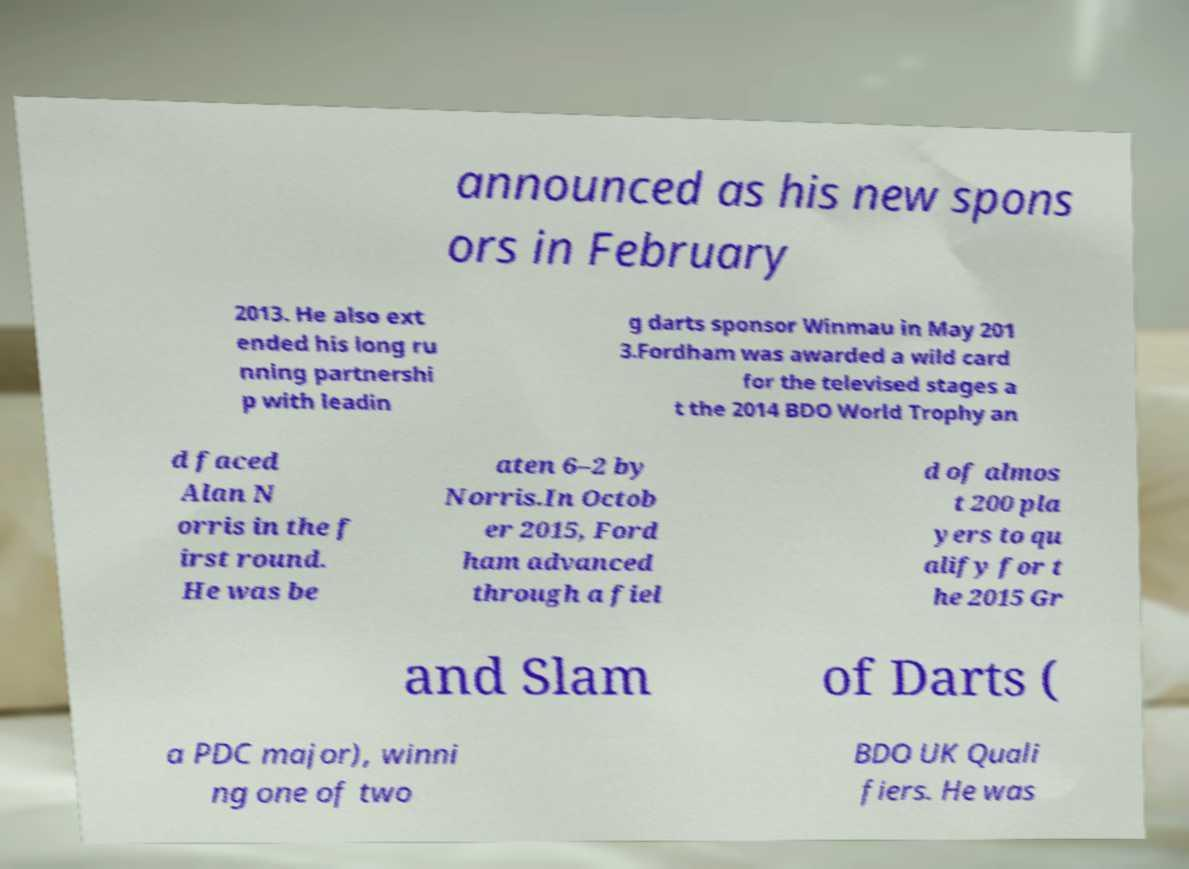I need the written content from this picture converted into text. Can you do that? announced as his new spons ors in February 2013. He also ext ended his long ru nning partnershi p with leadin g darts sponsor Winmau in May 201 3.Fordham was awarded a wild card for the televised stages a t the 2014 BDO World Trophy an d faced Alan N orris in the f irst round. He was be aten 6–2 by Norris.In Octob er 2015, Ford ham advanced through a fiel d of almos t 200 pla yers to qu alify for t he 2015 Gr and Slam of Darts ( a PDC major), winni ng one of two BDO UK Quali fiers. He was 